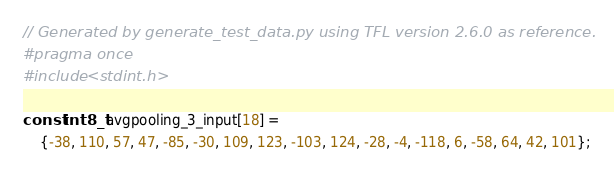<code> <loc_0><loc_0><loc_500><loc_500><_C_>// Generated by generate_test_data.py using TFL version 2.6.0 as reference.
#pragma once
#include <stdint.h>

const int8_t avgpooling_3_input[18] =
    {-38, 110, 57, 47, -85, -30, 109, 123, -103, 124, -28, -4, -118, 6, -58, 64, 42, 101};
</code> 